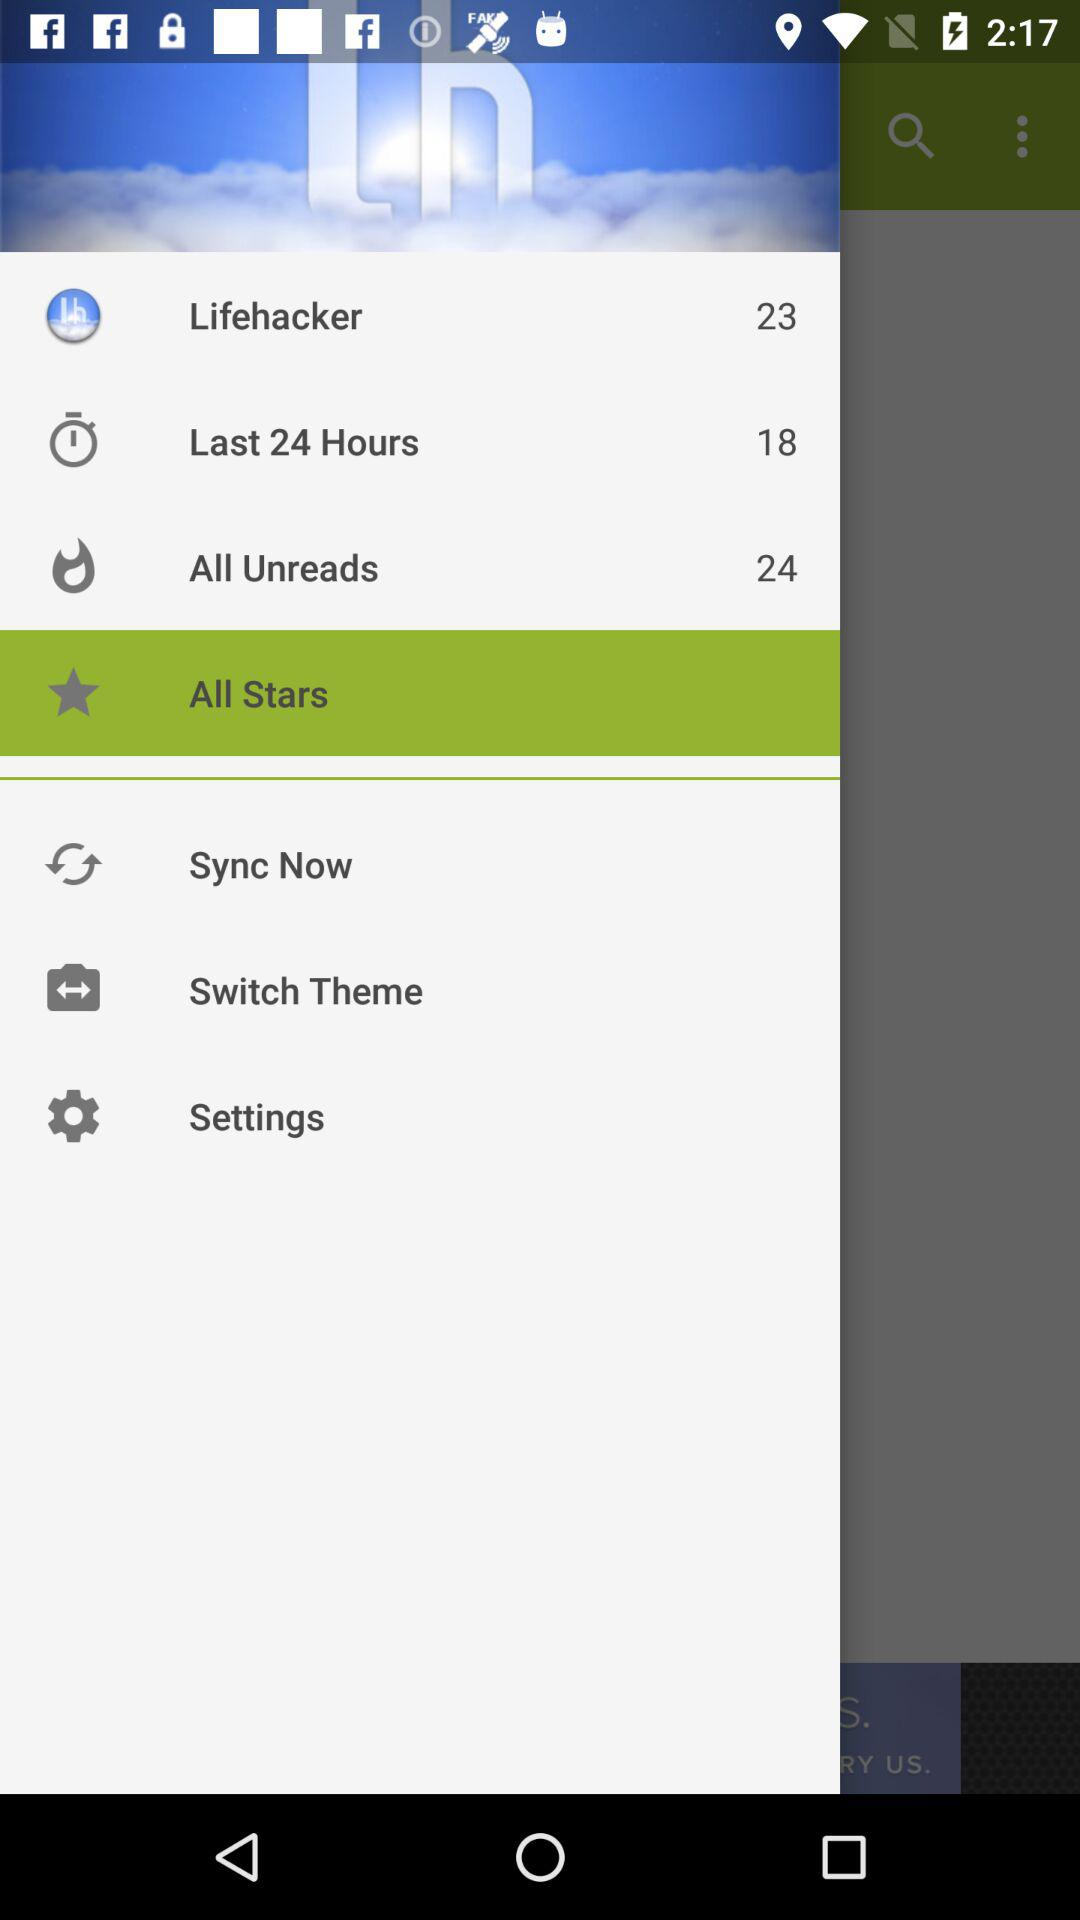What is the number in "Last 24 Hours"? The number is 18. 